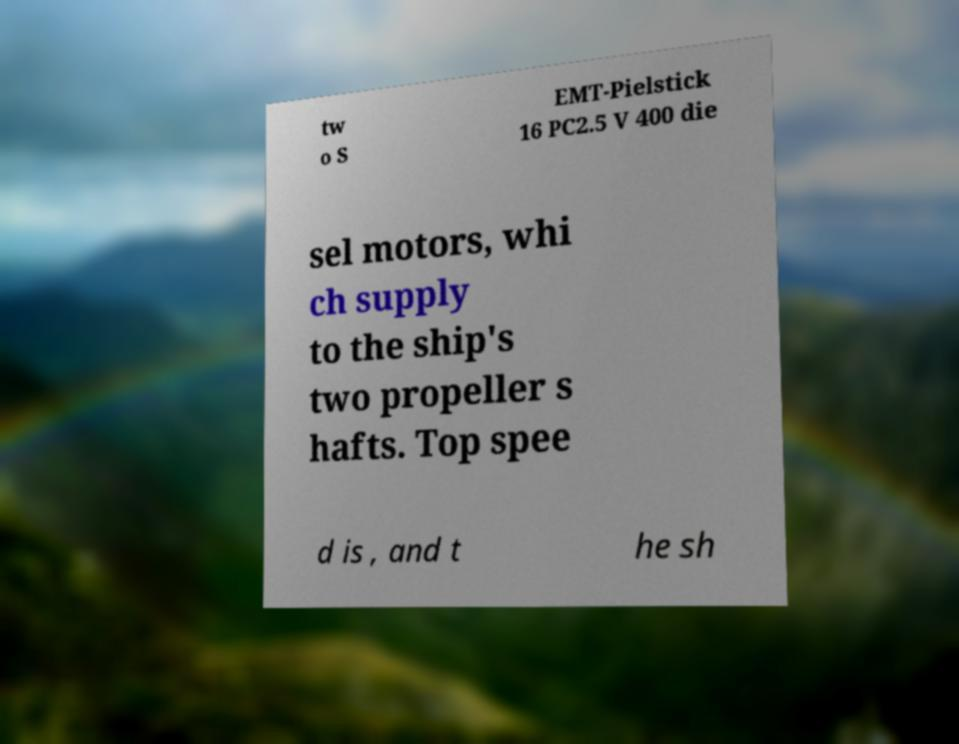Could you extract and type out the text from this image? tw o S EMT-Pielstick 16 PC2.5 V 400 die sel motors, whi ch supply to the ship's two propeller s hafts. Top spee d is , and t he sh 